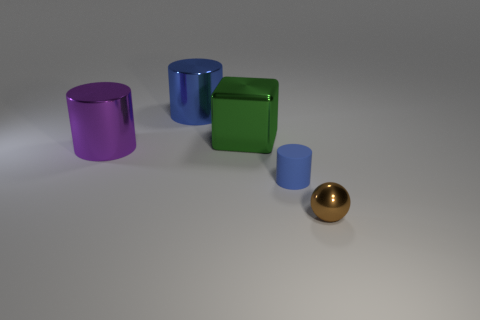Add 4 tiny yellow cylinders. How many objects exist? 9 Subtract all cubes. How many objects are left? 4 Subtract 0 gray spheres. How many objects are left? 5 Subtract all brown matte blocks. Subtract all small brown things. How many objects are left? 4 Add 2 big purple metal things. How many big purple metal things are left? 3 Add 1 green metallic objects. How many green metallic objects exist? 2 